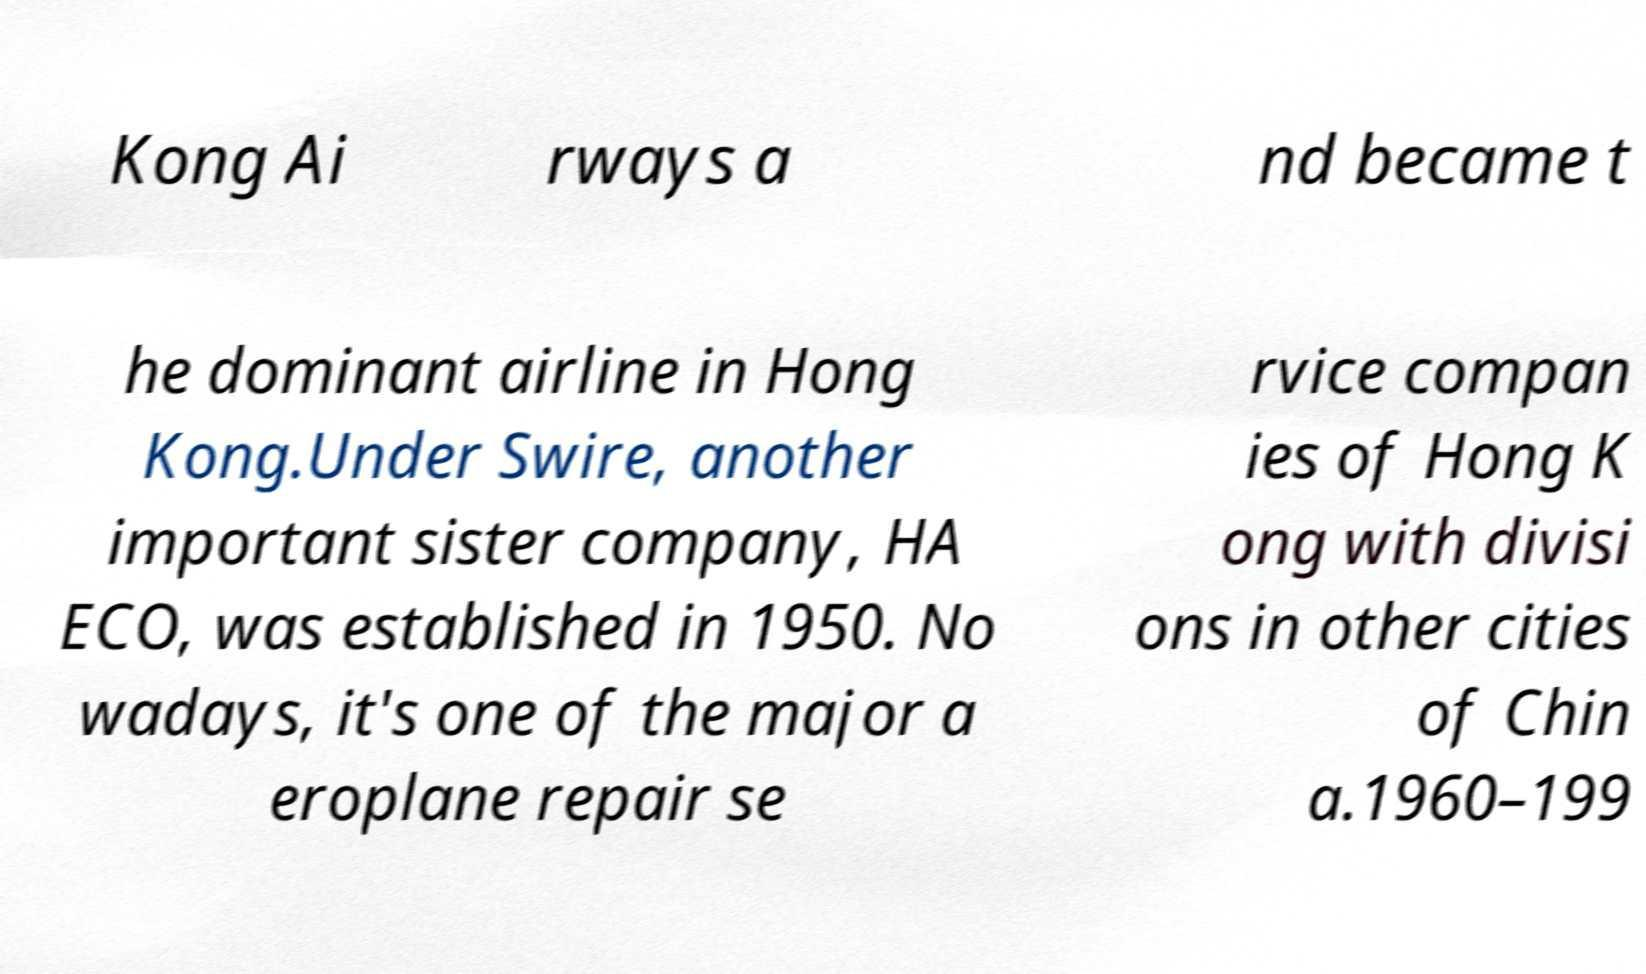What messages or text are displayed in this image? I need them in a readable, typed format. Kong Ai rways a nd became t he dominant airline in Hong Kong.Under Swire, another important sister company, HA ECO, was established in 1950. No wadays, it's one of the major a eroplane repair se rvice compan ies of Hong K ong with divisi ons in other cities of Chin a.1960–199 